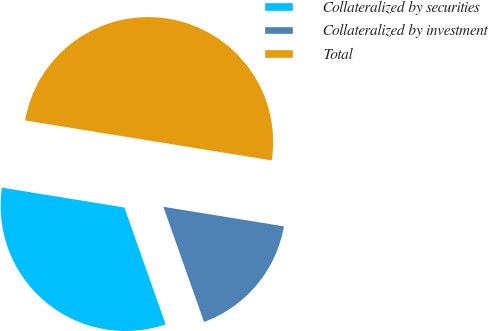<chart> <loc_0><loc_0><loc_500><loc_500><pie_chart><fcel>Collateralized by securities<fcel>Collateralized by investment<fcel>Total<nl><fcel>32.96%<fcel>17.04%<fcel>50.0%<nl></chart> 